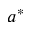<formula> <loc_0><loc_0><loc_500><loc_500>a ^ { * }</formula> 